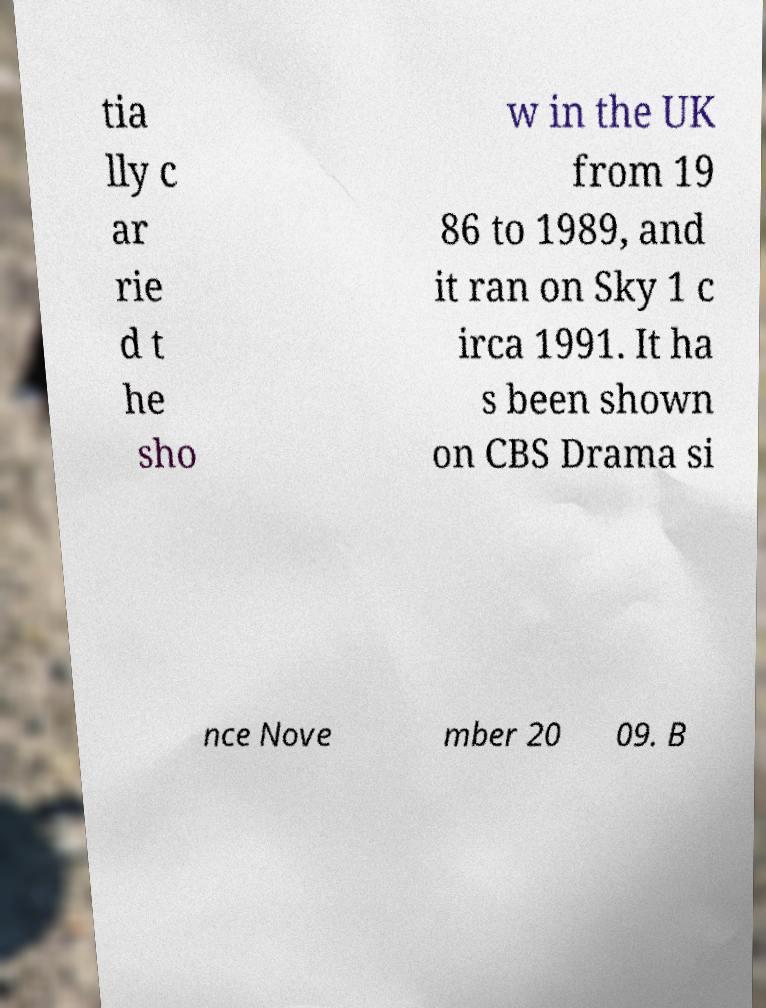Can you accurately transcribe the text from the provided image for me? tia lly c ar rie d t he sho w in the UK from 19 86 to 1989, and it ran on Sky 1 c irca 1991. It ha s been shown on CBS Drama si nce Nove mber 20 09. B 